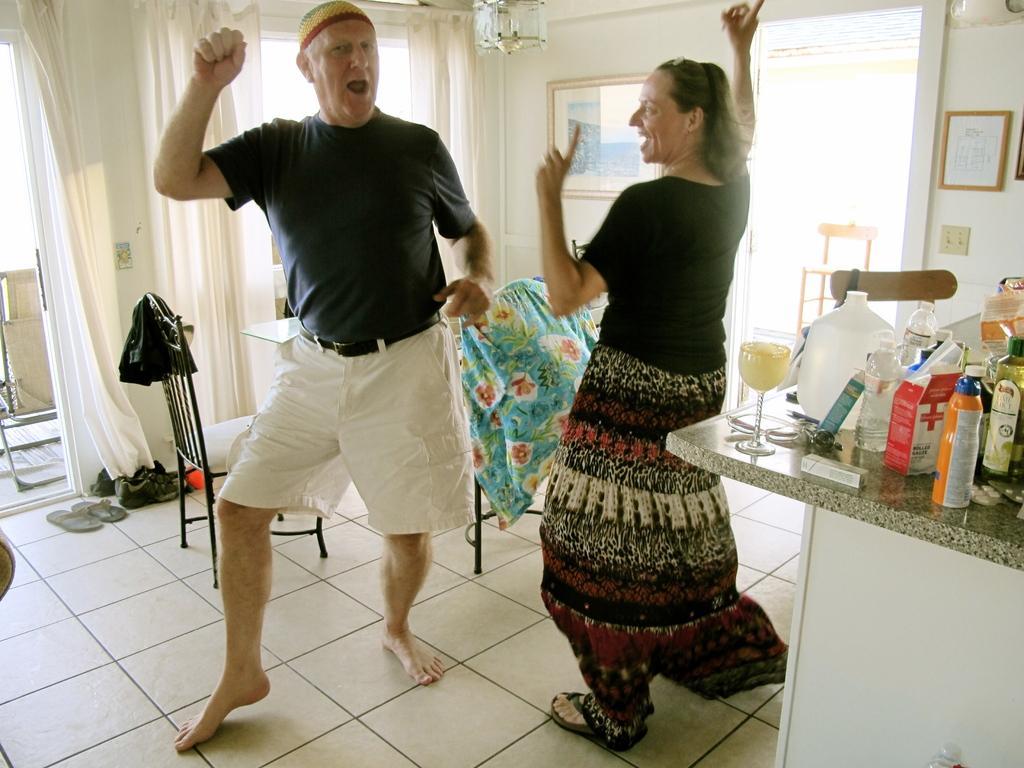Could you give a brief overview of what you see in this image? In this picture we can see 2 people dancing on the floor in a white room. On the right side, we can see a platform on which many bottles are kept. 